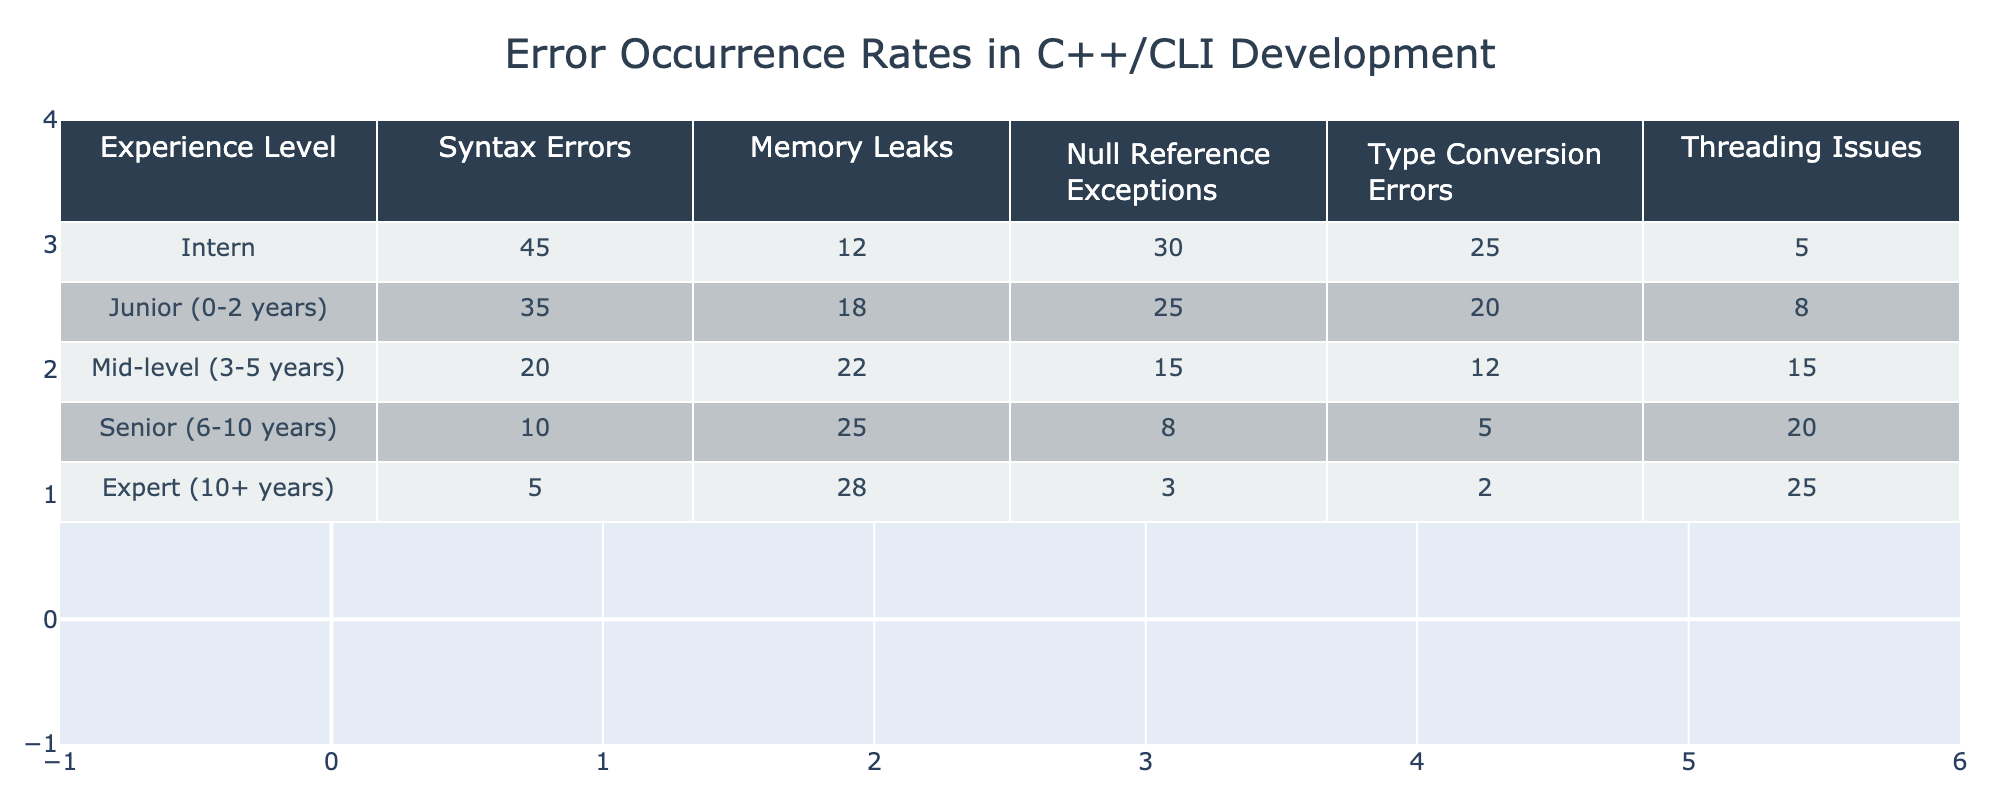What is the experience level with the highest number of syntax errors? Looking at the table, the 'Intern' level has the highest number of syntax errors, totaling 45.
Answer: Intern Which experience level shows the least number of memory leaks? The 'Expert (10+ years)' experience level shows the least number of memory leaks with a total of 5.
Answer: Expert (10+ years) How many total errors are reported by Junior developers? To find the total errors for Junior developers, we sum the values: 35 (Syntax Errors) + 18 (Memory Leaks) + 25 (Null Reference Exceptions) + 20 (Type Conversion Errors) + 8 (Threading Issues) = 106.
Answer: 106 Do Mid-level developers have more null reference exceptions than Senior developers? Mid-level developers have 15 null reference exceptions, while Senior developers have 8. Since 15 is greater than 8, the answer is yes.
Answer: Yes What is the average number of threading issues across all experience levels? To find the average, we first add the threading issues: 5 (Intern) + 8 (Junior) + 15 (Mid-level) + 20 (Senior) + 25 (Expert) = 73. Then, we divide by the number of experience levels (5), which gives us 73/5 = 14.6.
Answer: 14.6 Which experience level has the second highest occurrence of type conversion errors? By examining the values, the 'Junior (0-2 years)' level has 20 type conversion errors, and the 'Mid-level (3-5 years)' level has 12, making Junior the second highest.
Answer: Junior (0-2 years) Is it true that Senior developers have more memory leaks than Mid-level developers? Senior developers report 25 memory leaks, while Mid-level developers report 22. Since 25 is greater than 22, the statement is true.
Answer: True Which error type increases the most as experience rises from Junior to Senior? We observe the threading issues: Junior has 8, Senior has 20, so the increase is 12 (20 - 8). Other error types either decrease or show smaller increases. Thus, threading issues show the most significant increase.
Answer: Threading Issues Combine the syntax errors and null reference exceptions for the Intern level. What is the total? The total for the Intern level is 45 (Syntax Errors) + 30 (Null Reference Exceptions) = 75.
Answer: 75 What is the difference in the number of syntax errors between the Interns and the Experts? The difference is calculated as 45 (Intern) - 5 (Expert) = 40.
Answer: 40 